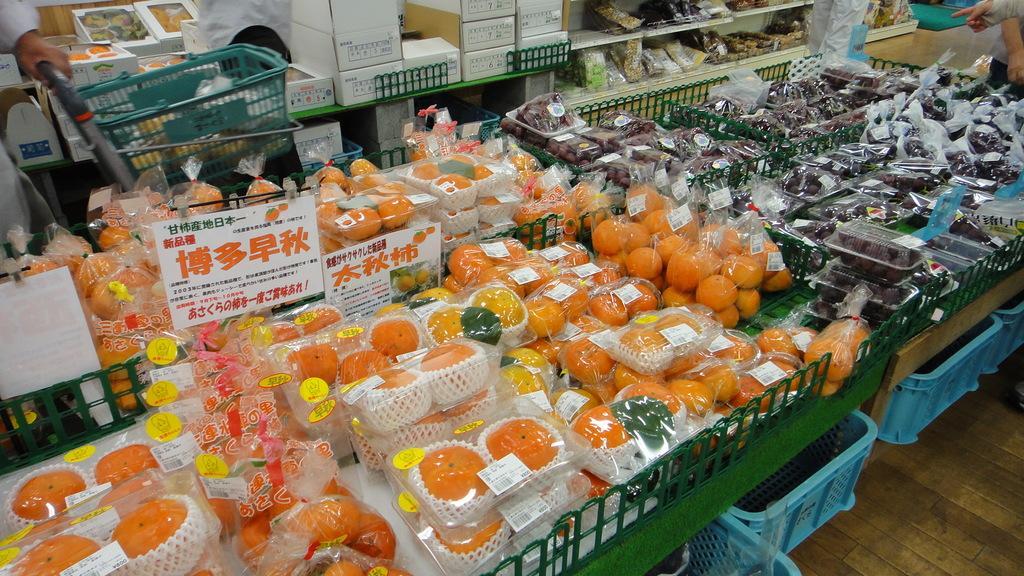In one or two sentences, can you explain what this image depicts? This image is taken indoors. At the bottom of the image there is a floor and there are a few baskets on the floor. In the middle of the image there is a table with many baskets of oranges packed with covers and many many fruits packed in the boxes. There are many boards with text on them. O the right side of the image there are two persons. In the background a person is holding a trolley in his hand and there are many boxes and packets on the shelves. 